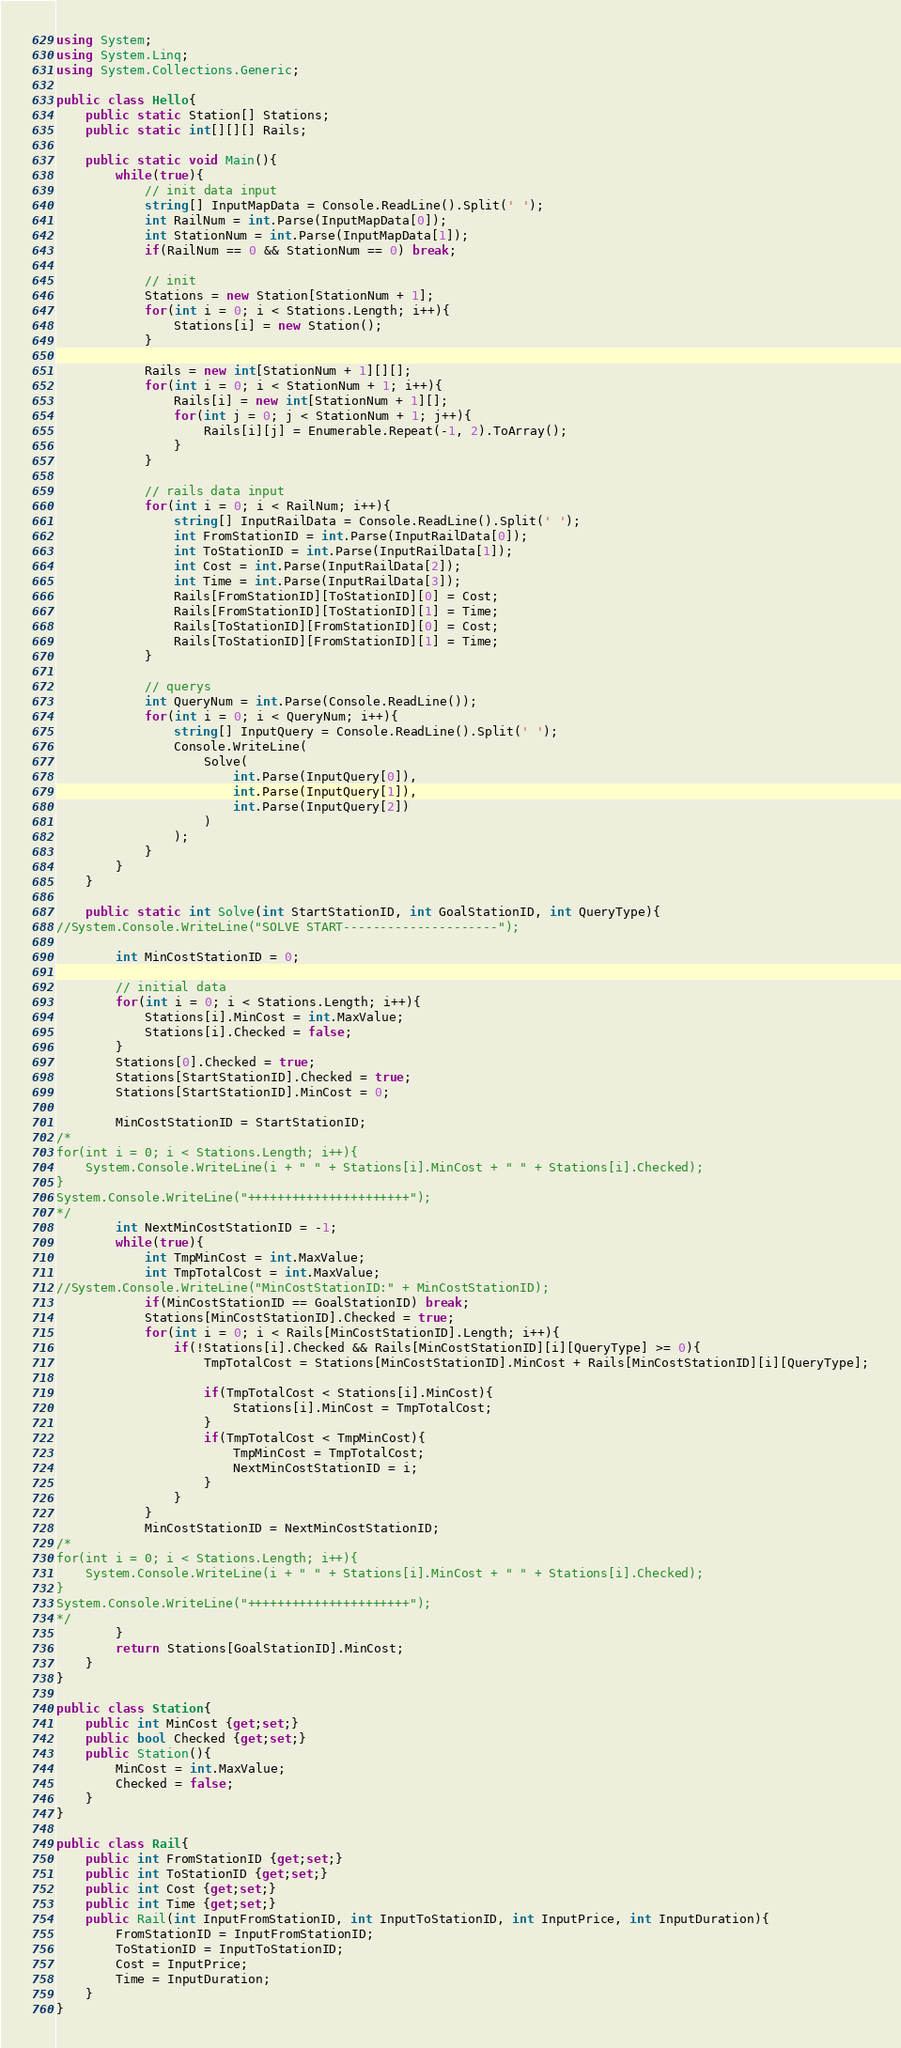Convert code to text. <code><loc_0><loc_0><loc_500><loc_500><_C#_>using System;
using System.Linq;
using System.Collections.Generic;

public class Hello{
    public static Station[] Stations;
    public static int[][][] Rails;
    
    public static void Main(){
        while(true){
            // init data input
            string[] InputMapData = Console.ReadLine().Split(' ');
            int RailNum = int.Parse(InputMapData[0]);
            int StationNum = int.Parse(InputMapData[1]);
            if(RailNum == 0 && StationNum == 0) break;

            // init
            Stations = new Station[StationNum + 1];
            for(int i = 0; i < Stations.Length; i++){
                Stations[i] = new Station();
            }

            Rails = new int[StationNum + 1][][];
            for(int i = 0; i < StationNum + 1; i++){
                Rails[i] = new int[StationNum + 1][];
                for(int j = 0; j < StationNum + 1; j++){
                    Rails[i][j] = Enumerable.Repeat(-1, 2).ToArray();
                }
            }

            // rails data input
            for(int i = 0; i < RailNum; i++){
                string[] InputRailData = Console.ReadLine().Split(' ');
                int FromStationID = int.Parse(InputRailData[0]);
                int ToStationID = int.Parse(InputRailData[1]);
                int Cost = int.Parse(InputRailData[2]);
                int Time = int.Parse(InputRailData[3]);
                Rails[FromStationID][ToStationID][0] = Cost;
                Rails[FromStationID][ToStationID][1] = Time;
                Rails[ToStationID][FromStationID][0] = Cost;
                Rails[ToStationID][FromStationID][1] = Time;
            }

            // querys
            int QueryNum = int.Parse(Console.ReadLine());
            for(int i = 0; i < QueryNum; i++){
                string[] InputQuery = Console.ReadLine().Split(' ');
                Console.WriteLine(
                    Solve(
                        int.Parse(InputQuery[0]),
                        int.Parse(InputQuery[1]),
                        int.Parse(InputQuery[2])
                    )
                );
            }
        }
    }
    
    public static int Solve(int StartStationID, int GoalStationID, int QueryType){
//System.Console.WriteLine("SOLVE START---------------------");

        int MinCostStationID = 0;
        
        // initial data
        for(int i = 0; i < Stations.Length; i++){
            Stations[i].MinCost = int.MaxValue;
            Stations[i].Checked = false;
        }
        Stations[0].Checked = true;
        Stations[StartStationID].Checked = true;
        Stations[StartStationID].MinCost = 0;

        MinCostStationID = StartStationID;
/*
for(int i = 0; i < Stations.Length; i++){
    System.Console.WriteLine(i + " " + Stations[i].MinCost + " " + Stations[i].Checked);
}
System.Console.WriteLine("++++++++++++++++++++++");
*/
        int NextMinCostStationID = -1;
        while(true){
            int TmpMinCost = int.MaxValue;
            int TmpTotalCost = int.MaxValue;
//System.Console.WriteLine("MinCostStationID:" + MinCostStationID);
            if(MinCostStationID == GoalStationID) break;
            Stations[MinCostStationID].Checked = true;
            for(int i = 0; i < Rails[MinCostStationID].Length; i++){
                if(!Stations[i].Checked && Rails[MinCostStationID][i][QueryType] >= 0){
                    TmpTotalCost = Stations[MinCostStationID].MinCost + Rails[MinCostStationID][i][QueryType];
  
                    if(TmpTotalCost < Stations[i].MinCost){
                        Stations[i].MinCost = TmpTotalCost;
                    }
                    if(TmpTotalCost < TmpMinCost){
                        TmpMinCost = TmpTotalCost;
                        NextMinCostStationID = i;
                    }
                }
            }
            MinCostStationID = NextMinCostStationID;
/*            
for(int i = 0; i < Stations.Length; i++){
    System.Console.WriteLine(i + " " + Stations[i].MinCost + " " + Stations[i].Checked);
}            
System.Console.WriteLine("++++++++++++++++++++++");
*/
        }
        return Stations[GoalStationID].MinCost;
    }
}

public class Station{
    public int MinCost {get;set;}
    public bool Checked {get;set;}
    public Station(){
        MinCost = int.MaxValue;
        Checked = false;
    }
}

public class Rail{
    public int FromStationID {get;set;}
    public int ToStationID {get;set;}
    public int Cost {get;set;}
    public int Time {get;set;}
    public Rail(int InputFromStationID, int InputToStationID, int InputPrice, int InputDuration){
        FromStationID = InputFromStationID;
        ToStationID = InputToStationID;
        Cost = InputPrice;
        Time = InputDuration;
    }
}</code> 